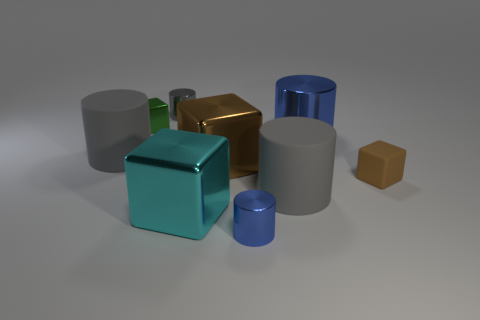There is a small thing that is in front of the brown rubber cube; is it the same color as the big metallic cylinder?
Ensure brevity in your answer.  Yes. What is the shape of the metallic object that is the same color as the small matte object?
Offer a very short reply. Cube. The small rubber thing is what color?
Your answer should be compact. Brown. What number of tiny gray objects have the same shape as the green shiny thing?
Offer a very short reply. 0. There is a shiny block that is the same size as the gray metal cylinder; what color is it?
Your response must be concise. Green. Are any small cyan matte cubes visible?
Provide a short and direct response. No. What is the shape of the big matte object that is in front of the tiny brown rubber thing?
Your response must be concise. Cylinder. How many tiny objects are behind the big shiny cylinder and to the right of the small green shiny cube?
Make the answer very short. 1. Are there any big brown objects made of the same material as the tiny gray thing?
Give a very brief answer. Yes. The cube that is the same color as the small matte thing is what size?
Offer a terse response. Large. 